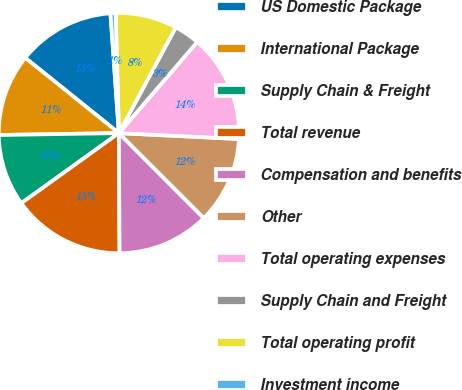Convert chart. <chart><loc_0><loc_0><loc_500><loc_500><pie_chart><fcel>US Domestic Package<fcel>International Package<fcel>Supply Chain & Freight<fcel>Total revenue<fcel>Compensation and benefits<fcel>Other<fcel>Total operating expenses<fcel>Supply Chain and Freight<fcel>Total operating profit<fcel>Investment income<nl><fcel>13.1%<fcel>11.03%<fcel>9.66%<fcel>15.17%<fcel>12.41%<fcel>11.72%<fcel>14.48%<fcel>3.45%<fcel>8.28%<fcel>0.69%<nl></chart> 